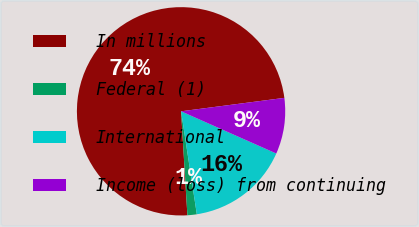Convert chart to OTSL. <chart><loc_0><loc_0><loc_500><loc_500><pie_chart><fcel>In millions<fcel>Federal (1)<fcel>International<fcel>Income (loss) from continuing<nl><fcel>73.91%<fcel>1.45%<fcel>15.94%<fcel>8.7%<nl></chart> 